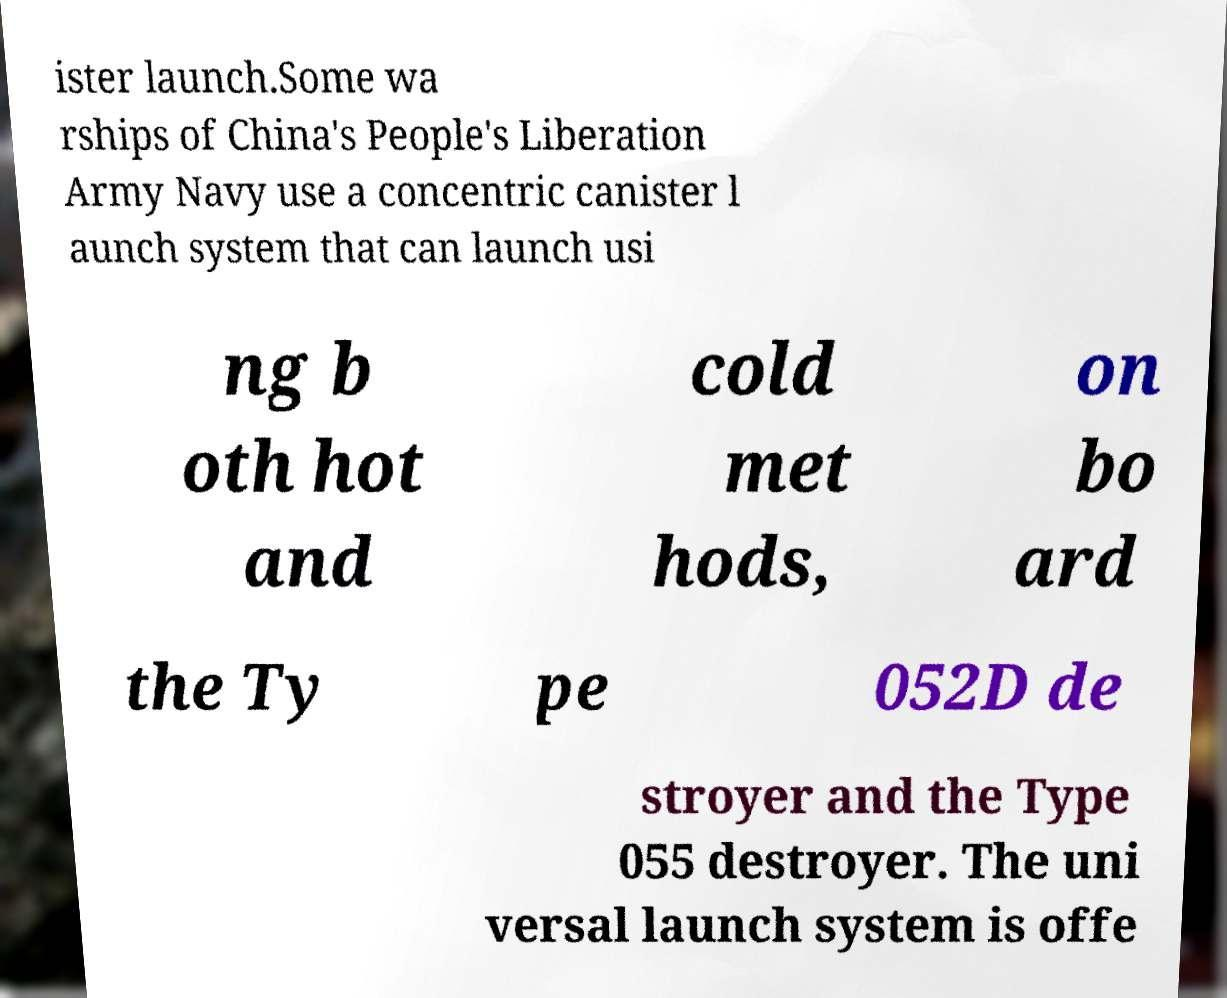Could you assist in decoding the text presented in this image and type it out clearly? ister launch.Some wa rships of China's People's Liberation Army Navy use a concentric canister l aunch system that can launch usi ng b oth hot and cold met hods, on bo ard the Ty pe 052D de stroyer and the Type 055 destroyer. The uni versal launch system is offe 